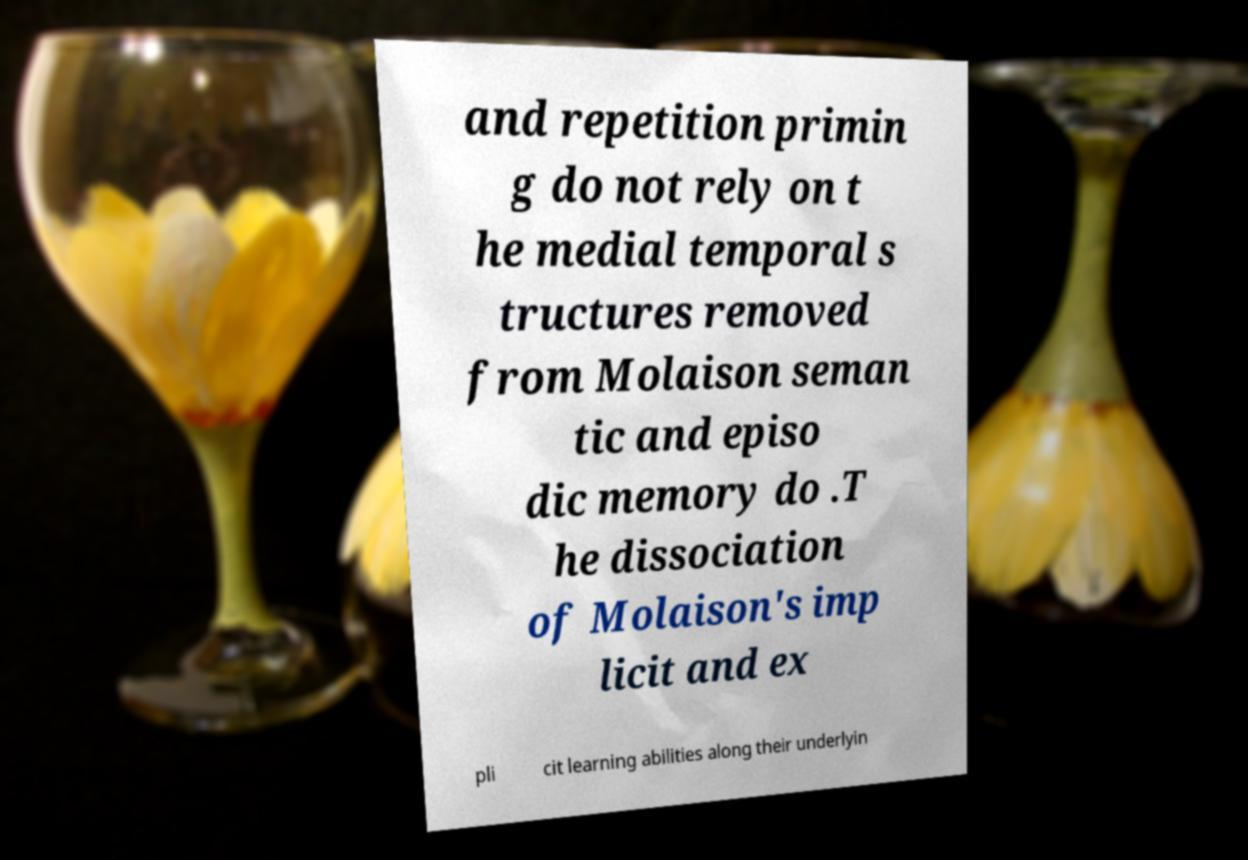What messages or text are displayed in this image? I need them in a readable, typed format. and repetition primin g do not rely on t he medial temporal s tructures removed from Molaison seman tic and episo dic memory do .T he dissociation of Molaison's imp licit and ex pli cit learning abilities along their underlyin 